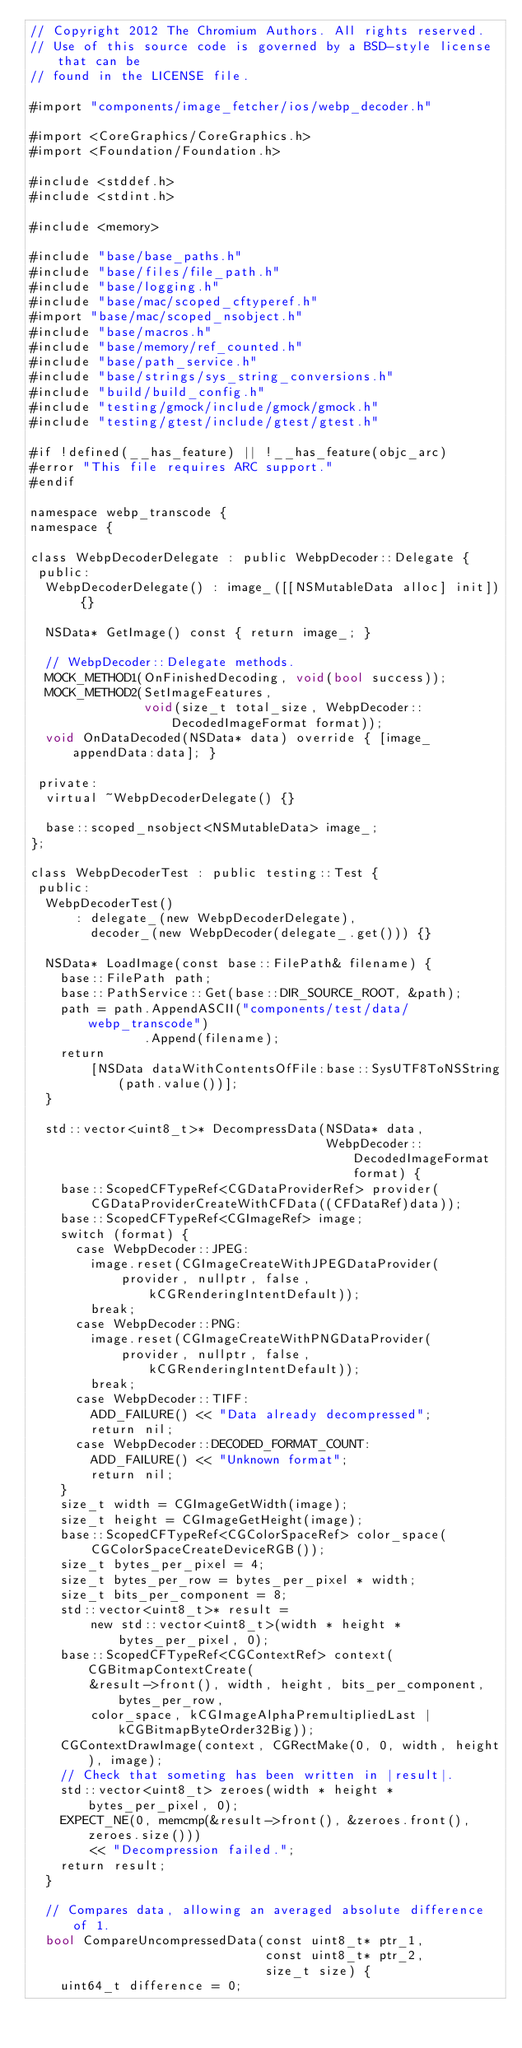<code> <loc_0><loc_0><loc_500><loc_500><_ObjectiveC_>// Copyright 2012 The Chromium Authors. All rights reserved.
// Use of this source code is governed by a BSD-style license that can be
// found in the LICENSE file.

#import "components/image_fetcher/ios/webp_decoder.h"

#import <CoreGraphics/CoreGraphics.h>
#import <Foundation/Foundation.h>

#include <stddef.h>
#include <stdint.h>

#include <memory>

#include "base/base_paths.h"
#include "base/files/file_path.h"
#include "base/logging.h"
#include "base/mac/scoped_cftyperef.h"
#import "base/mac/scoped_nsobject.h"
#include "base/macros.h"
#include "base/memory/ref_counted.h"
#include "base/path_service.h"
#include "base/strings/sys_string_conversions.h"
#include "build/build_config.h"
#include "testing/gmock/include/gmock/gmock.h"
#include "testing/gtest/include/gtest/gtest.h"

#if !defined(__has_feature) || !__has_feature(objc_arc)
#error "This file requires ARC support."
#endif

namespace webp_transcode {
namespace {

class WebpDecoderDelegate : public WebpDecoder::Delegate {
 public:
  WebpDecoderDelegate() : image_([[NSMutableData alloc] init]) {}

  NSData* GetImage() const { return image_; }

  // WebpDecoder::Delegate methods.
  MOCK_METHOD1(OnFinishedDecoding, void(bool success));
  MOCK_METHOD2(SetImageFeatures,
               void(size_t total_size, WebpDecoder::DecodedImageFormat format));
  void OnDataDecoded(NSData* data) override { [image_ appendData:data]; }

 private:
  virtual ~WebpDecoderDelegate() {}

  base::scoped_nsobject<NSMutableData> image_;
};

class WebpDecoderTest : public testing::Test {
 public:
  WebpDecoderTest()
      : delegate_(new WebpDecoderDelegate),
        decoder_(new WebpDecoder(delegate_.get())) {}

  NSData* LoadImage(const base::FilePath& filename) {
    base::FilePath path;
    base::PathService::Get(base::DIR_SOURCE_ROOT, &path);
    path = path.AppendASCII("components/test/data/webp_transcode")
               .Append(filename);
    return
        [NSData dataWithContentsOfFile:base::SysUTF8ToNSString(path.value())];
  }

  std::vector<uint8_t>* DecompressData(NSData* data,
                                       WebpDecoder::DecodedImageFormat format) {
    base::ScopedCFTypeRef<CGDataProviderRef> provider(
        CGDataProviderCreateWithCFData((CFDataRef)data));
    base::ScopedCFTypeRef<CGImageRef> image;
    switch (format) {
      case WebpDecoder::JPEG:
        image.reset(CGImageCreateWithJPEGDataProvider(
            provider, nullptr, false, kCGRenderingIntentDefault));
        break;
      case WebpDecoder::PNG:
        image.reset(CGImageCreateWithPNGDataProvider(
            provider, nullptr, false, kCGRenderingIntentDefault));
        break;
      case WebpDecoder::TIFF:
        ADD_FAILURE() << "Data already decompressed";
        return nil;
      case WebpDecoder::DECODED_FORMAT_COUNT:
        ADD_FAILURE() << "Unknown format";
        return nil;
    }
    size_t width = CGImageGetWidth(image);
    size_t height = CGImageGetHeight(image);
    base::ScopedCFTypeRef<CGColorSpaceRef> color_space(
        CGColorSpaceCreateDeviceRGB());
    size_t bytes_per_pixel = 4;
    size_t bytes_per_row = bytes_per_pixel * width;
    size_t bits_per_component = 8;
    std::vector<uint8_t>* result =
        new std::vector<uint8_t>(width * height * bytes_per_pixel, 0);
    base::ScopedCFTypeRef<CGContextRef> context(CGBitmapContextCreate(
        &result->front(), width, height, bits_per_component, bytes_per_row,
        color_space, kCGImageAlphaPremultipliedLast | kCGBitmapByteOrder32Big));
    CGContextDrawImage(context, CGRectMake(0, 0, width, height), image);
    // Check that someting has been written in |result|.
    std::vector<uint8_t> zeroes(width * height * bytes_per_pixel, 0);
    EXPECT_NE(0, memcmp(&result->front(), &zeroes.front(), zeroes.size()))
        << "Decompression failed.";
    return result;
  }

  // Compares data, allowing an averaged absolute difference of 1.
  bool CompareUncompressedData(const uint8_t* ptr_1,
                               const uint8_t* ptr_2,
                               size_t size) {
    uint64_t difference = 0;</code> 